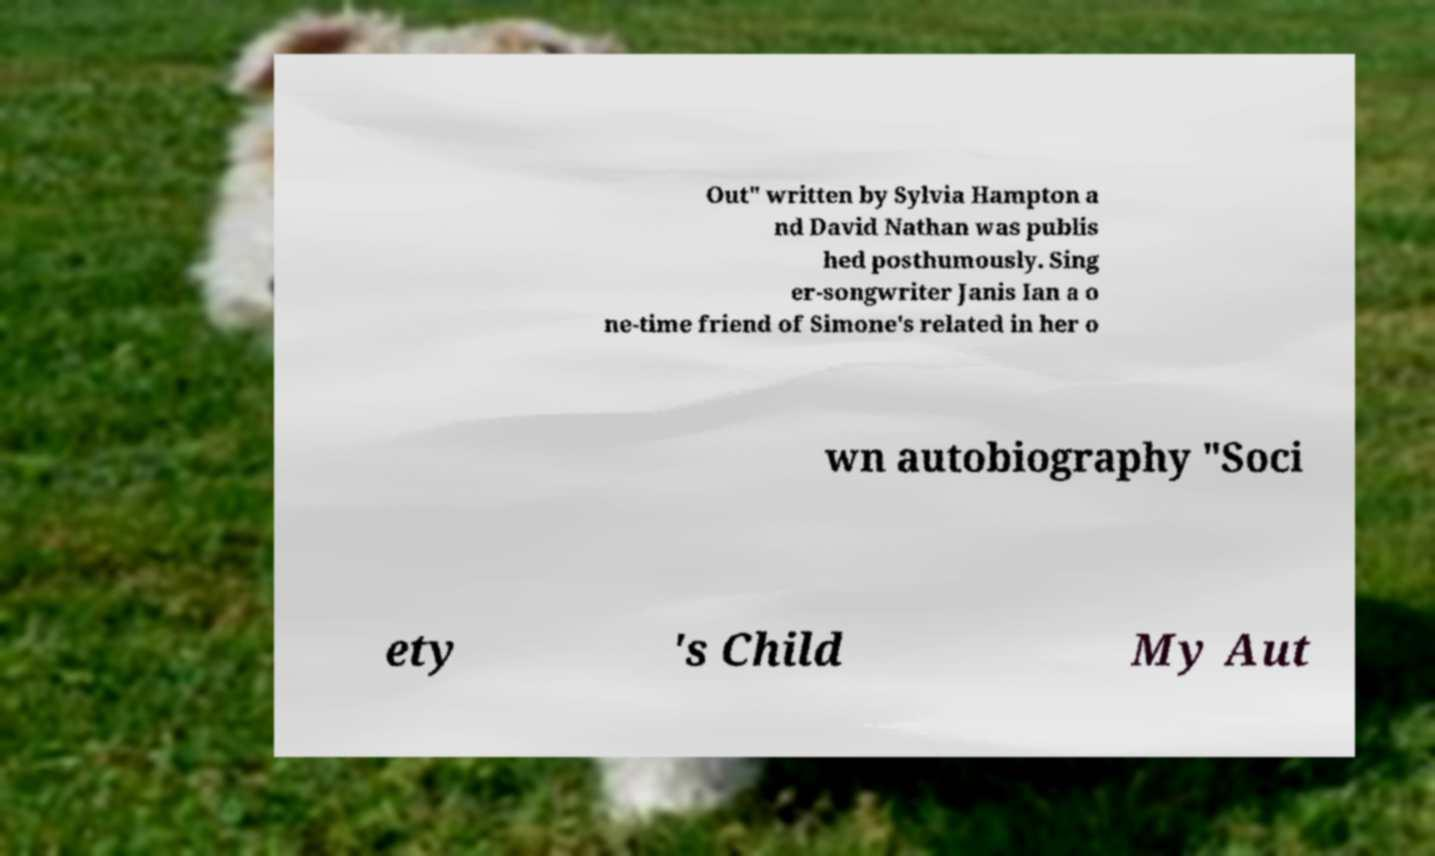Please read and relay the text visible in this image. What does it say? Out" written by Sylvia Hampton a nd David Nathan was publis hed posthumously. Sing er-songwriter Janis Ian a o ne-time friend of Simone's related in her o wn autobiography "Soci ety 's Child My Aut 